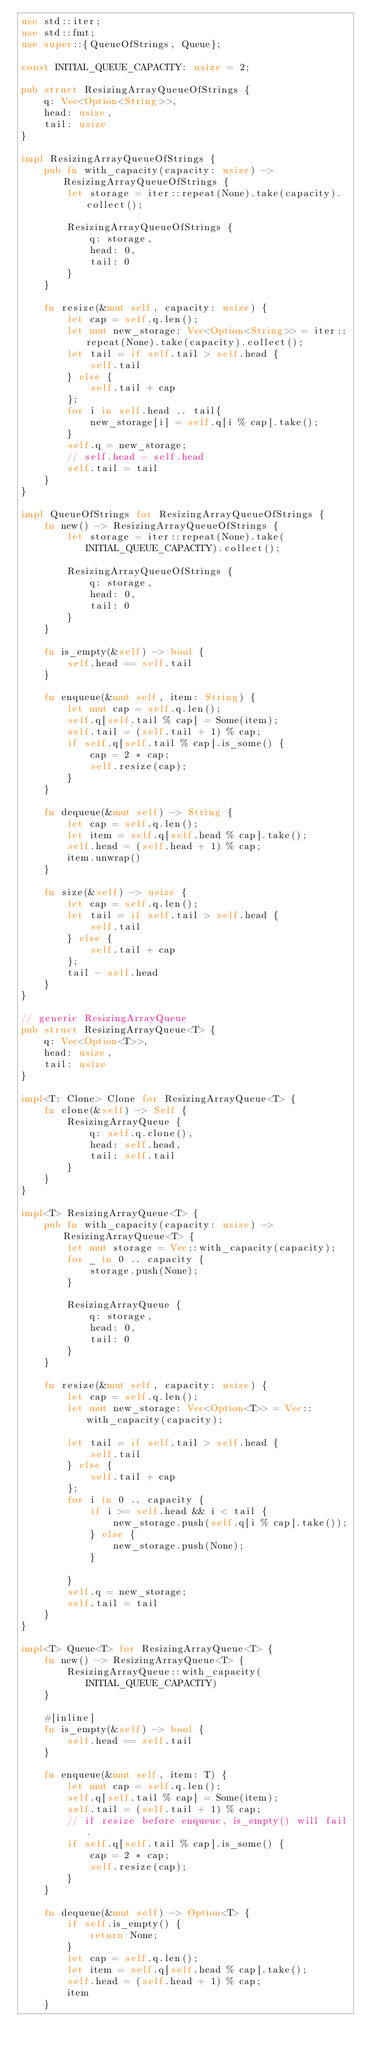Convert code to text. <code><loc_0><loc_0><loc_500><loc_500><_Rust_>use std::iter;
use std::fmt;
use super::{QueueOfStrings, Queue};

const INITIAL_QUEUE_CAPACITY: usize = 2;

pub struct ResizingArrayQueueOfStrings {
    q: Vec<Option<String>>,
    head: usize,
    tail: usize
}

impl ResizingArrayQueueOfStrings {
    pub fn with_capacity(capacity: usize) -> ResizingArrayQueueOfStrings {
        let storage = iter::repeat(None).take(capacity).collect();

        ResizingArrayQueueOfStrings {
            q: storage,
            head: 0,
            tail: 0
        }
    }

    fn resize(&mut self, capacity: usize) {
        let cap = self.q.len();
        let mut new_storage: Vec<Option<String>> = iter::repeat(None).take(capacity).collect();
        let tail = if self.tail > self.head {
            self.tail
        } else {
            self.tail + cap
        };
        for i in self.head .. tail{
            new_storage[i] = self.q[i % cap].take();
        }
        self.q = new_storage;
        // self.head = self.head
        self.tail = tail
    }
}

impl QueueOfStrings for ResizingArrayQueueOfStrings {
    fn new() -> ResizingArrayQueueOfStrings {
        let storage = iter::repeat(None).take(INITIAL_QUEUE_CAPACITY).collect();

        ResizingArrayQueueOfStrings {
            q: storage,
            head: 0,
            tail: 0
        }
    }

    fn is_empty(&self) -> bool {
        self.head == self.tail
    }

    fn enqueue(&mut self, item: String) {
        let mut cap = self.q.len();
        self.q[self.tail % cap] = Some(item);
        self.tail = (self.tail + 1) % cap;
        if self.q[self.tail % cap].is_some() {
            cap = 2 * cap;
            self.resize(cap);
        }
    }

    fn dequeue(&mut self) -> String {
        let cap = self.q.len();
        let item = self.q[self.head % cap].take();
        self.head = (self.head + 1) % cap;
        item.unwrap()
    }

    fn size(&self) -> usize {
        let cap = self.q.len();
        let tail = if self.tail > self.head {
            self.tail
        } else {
            self.tail + cap
        };
        tail - self.head
    }
}

// generic ResizingArrayQueue
pub struct ResizingArrayQueue<T> {
    q: Vec<Option<T>>,
    head: usize,
    tail: usize
}

impl<T: Clone> Clone for ResizingArrayQueue<T> {
    fn clone(&self) -> Self {
        ResizingArrayQueue {
            q: self.q.clone(),
            head: self.head,
            tail: self.tail
        }
    }
}

impl<T> ResizingArrayQueue<T> {
    pub fn with_capacity(capacity: usize) -> ResizingArrayQueue<T> {
        let mut storage = Vec::with_capacity(capacity);
        for _ in 0 .. capacity {
            storage.push(None);
        }

        ResizingArrayQueue {
            q: storage,
            head: 0,
            tail: 0
        }
    }

    fn resize(&mut self, capacity: usize) {
        let cap = self.q.len();
        let mut new_storage: Vec<Option<T>> = Vec::with_capacity(capacity);

        let tail = if self.tail > self.head {
            self.tail
        } else {
            self.tail + cap
        };
        for i in 0 .. capacity {
            if i >= self.head && i < tail {
                new_storage.push(self.q[i % cap].take());
            } else {
                new_storage.push(None);
            }

        }
        self.q = new_storage;
        self.tail = tail
    }
}

impl<T> Queue<T> for ResizingArrayQueue<T> {
    fn new() -> ResizingArrayQueue<T> {
        ResizingArrayQueue::with_capacity(INITIAL_QUEUE_CAPACITY)
    }

    #[inline]
    fn is_empty(&self) -> bool {
        self.head == self.tail
    }

    fn enqueue(&mut self, item: T) {
        let mut cap = self.q.len();
        self.q[self.tail % cap] = Some(item);
        self.tail = (self.tail + 1) % cap;
        // if resize before enqueue, is_empty() will fail.
        if self.q[self.tail % cap].is_some() {
            cap = 2 * cap;
            self.resize(cap);
        }
    }

    fn dequeue(&mut self) -> Option<T> {
        if self.is_empty() {
            return None;
        }
        let cap = self.q.len();
        let item = self.q[self.head % cap].take();
        self.head = (self.head + 1) % cap;
        item
    }
</code> 